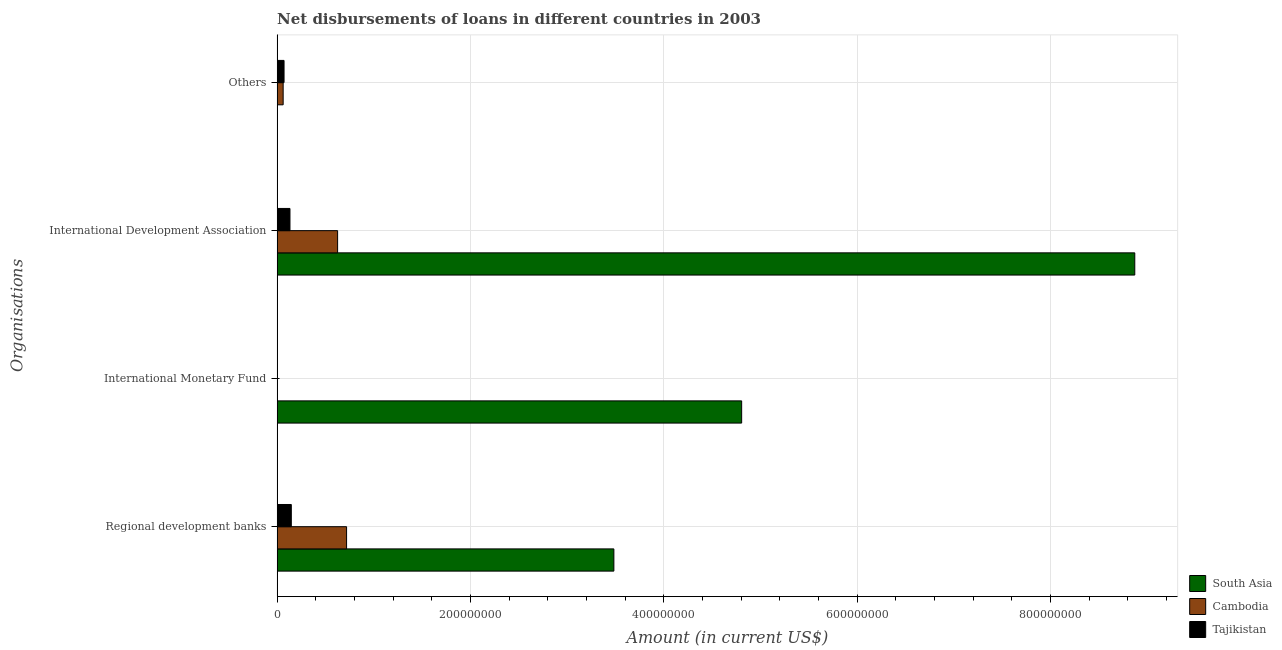How many different coloured bars are there?
Keep it short and to the point. 3. Are the number of bars per tick equal to the number of legend labels?
Your answer should be compact. No. How many bars are there on the 1st tick from the bottom?
Your answer should be very brief. 3. What is the label of the 1st group of bars from the top?
Keep it short and to the point. Others. What is the amount of loan disimbursed by international development association in Cambodia?
Offer a terse response. 6.26e+07. Across all countries, what is the maximum amount of loan disimbursed by international development association?
Offer a terse response. 8.87e+08. Across all countries, what is the minimum amount of loan disimbursed by regional development banks?
Make the answer very short. 1.47e+07. In which country was the amount of loan disimbursed by other organisations maximum?
Your answer should be very brief. Tajikistan. What is the total amount of loan disimbursed by international development association in the graph?
Your response must be concise. 9.63e+08. What is the difference between the amount of loan disimbursed by regional development banks in South Asia and that in Tajikistan?
Keep it short and to the point. 3.34e+08. What is the difference between the amount of loan disimbursed by regional development banks in South Asia and the amount of loan disimbursed by international development association in Tajikistan?
Offer a very short reply. 3.35e+08. What is the average amount of loan disimbursed by international development association per country?
Provide a succinct answer. 3.21e+08. What is the difference between the amount of loan disimbursed by other organisations and amount of loan disimbursed by international development association in Tajikistan?
Your answer should be compact. -6.12e+06. In how many countries, is the amount of loan disimbursed by international monetary fund greater than 160000000 US$?
Make the answer very short. 1. What is the ratio of the amount of loan disimbursed by international development association in South Asia to that in Cambodia?
Your answer should be very brief. 14.18. Is the difference between the amount of loan disimbursed by regional development banks in South Asia and Tajikistan greater than the difference between the amount of loan disimbursed by international development association in South Asia and Tajikistan?
Keep it short and to the point. No. What is the difference between the highest and the second highest amount of loan disimbursed by international development association?
Your answer should be very brief. 8.25e+08. What is the difference between the highest and the lowest amount of loan disimbursed by other organisations?
Make the answer very short. 7.17e+06. Is the sum of the amount of loan disimbursed by international development association in Cambodia and Tajikistan greater than the maximum amount of loan disimbursed by other organisations across all countries?
Offer a terse response. Yes. Is it the case that in every country, the sum of the amount of loan disimbursed by international development association and amount of loan disimbursed by regional development banks is greater than the sum of amount of loan disimbursed by other organisations and amount of loan disimbursed by international monetary fund?
Your answer should be compact. No. How many bars are there?
Make the answer very short. 9. Are all the bars in the graph horizontal?
Your response must be concise. Yes. How many countries are there in the graph?
Your answer should be compact. 3. How many legend labels are there?
Provide a short and direct response. 3. How are the legend labels stacked?
Your response must be concise. Vertical. What is the title of the graph?
Provide a short and direct response. Net disbursements of loans in different countries in 2003. Does "Cayman Islands" appear as one of the legend labels in the graph?
Provide a short and direct response. No. What is the label or title of the X-axis?
Offer a very short reply. Amount (in current US$). What is the label or title of the Y-axis?
Your response must be concise. Organisations. What is the Amount (in current US$) in South Asia in Regional development banks?
Offer a terse response. 3.48e+08. What is the Amount (in current US$) of Cambodia in Regional development banks?
Provide a short and direct response. 7.18e+07. What is the Amount (in current US$) of Tajikistan in Regional development banks?
Offer a terse response. 1.47e+07. What is the Amount (in current US$) of South Asia in International Monetary Fund?
Your answer should be very brief. 4.80e+08. What is the Amount (in current US$) of Cambodia in International Monetary Fund?
Keep it short and to the point. 0. What is the Amount (in current US$) in Tajikistan in International Monetary Fund?
Your answer should be compact. 0. What is the Amount (in current US$) of South Asia in International Development Association?
Your response must be concise. 8.87e+08. What is the Amount (in current US$) of Cambodia in International Development Association?
Ensure brevity in your answer.  6.26e+07. What is the Amount (in current US$) of Tajikistan in International Development Association?
Offer a terse response. 1.33e+07. What is the Amount (in current US$) in Cambodia in Others?
Your response must be concise. 6.24e+06. What is the Amount (in current US$) of Tajikistan in Others?
Your response must be concise. 7.17e+06. Across all Organisations, what is the maximum Amount (in current US$) of South Asia?
Provide a short and direct response. 8.87e+08. Across all Organisations, what is the maximum Amount (in current US$) in Cambodia?
Provide a succinct answer. 7.18e+07. Across all Organisations, what is the maximum Amount (in current US$) in Tajikistan?
Your answer should be compact. 1.47e+07. Across all Organisations, what is the minimum Amount (in current US$) in Cambodia?
Offer a terse response. 0. Across all Organisations, what is the minimum Amount (in current US$) of Tajikistan?
Give a very brief answer. 0. What is the total Amount (in current US$) of South Asia in the graph?
Your response must be concise. 1.72e+09. What is the total Amount (in current US$) in Cambodia in the graph?
Your answer should be compact. 1.41e+08. What is the total Amount (in current US$) in Tajikistan in the graph?
Provide a short and direct response. 3.51e+07. What is the difference between the Amount (in current US$) of South Asia in Regional development banks and that in International Monetary Fund?
Your response must be concise. -1.32e+08. What is the difference between the Amount (in current US$) in South Asia in Regional development banks and that in International Development Association?
Give a very brief answer. -5.39e+08. What is the difference between the Amount (in current US$) in Cambodia in Regional development banks and that in International Development Association?
Offer a terse response. 9.28e+06. What is the difference between the Amount (in current US$) in Tajikistan in Regional development banks and that in International Development Association?
Offer a very short reply. 1.40e+06. What is the difference between the Amount (in current US$) of Cambodia in Regional development banks and that in Others?
Your answer should be very brief. 6.56e+07. What is the difference between the Amount (in current US$) in Tajikistan in Regional development banks and that in Others?
Provide a short and direct response. 7.51e+06. What is the difference between the Amount (in current US$) of South Asia in International Monetary Fund and that in International Development Association?
Ensure brevity in your answer.  -4.07e+08. What is the difference between the Amount (in current US$) in Cambodia in International Development Association and that in Others?
Make the answer very short. 5.63e+07. What is the difference between the Amount (in current US$) of Tajikistan in International Development Association and that in Others?
Ensure brevity in your answer.  6.12e+06. What is the difference between the Amount (in current US$) in South Asia in Regional development banks and the Amount (in current US$) in Cambodia in International Development Association?
Provide a succinct answer. 2.86e+08. What is the difference between the Amount (in current US$) in South Asia in Regional development banks and the Amount (in current US$) in Tajikistan in International Development Association?
Offer a terse response. 3.35e+08. What is the difference between the Amount (in current US$) of Cambodia in Regional development banks and the Amount (in current US$) of Tajikistan in International Development Association?
Give a very brief answer. 5.86e+07. What is the difference between the Amount (in current US$) of South Asia in Regional development banks and the Amount (in current US$) of Cambodia in Others?
Ensure brevity in your answer.  3.42e+08. What is the difference between the Amount (in current US$) in South Asia in Regional development banks and the Amount (in current US$) in Tajikistan in Others?
Keep it short and to the point. 3.41e+08. What is the difference between the Amount (in current US$) in Cambodia in Regional development banks and the Amount (in current US$) in Tajikistan in Others?
Ensure brevity in your answer.  6.47e+07. What is the difference between the Amount (in current US$) in South Asia in International Monetary Fund and the Amount (in current US$) in Cambodia in International Development Association?
Ensure brevity in your answer.  4.18e+08. What is the difference between the Amount (in current US$) of South Asia in International Monetary Fund and the Amount (in current US$) of Tajikistan in International Development Association?
Your answer should be very brief. 4.67e+08. What is the difference between the Amount (in current US$) in South Asia in International Monetary Fund and the Amount (in current US$) in Cambodia in Others?
Offer a very short reply. 4.74e+08. What is the difference between the Amount (in current US$) in South Asia in International Monetary Fund and the Amount (in current US$) in Tajikistan in Others?
Your answer should be very brief. 4.73e+08. What is the difference between the Amount (in current US$) of South Asia in International Development Association and the Amount (in current US$) of Cambodia in Others?
Give a very brief answer. 8.81e+08. What is the difference between the Amount (in current US$) of South Asia in International Development Association and the Amount (in current US$) of Tajikistan in Others?
Keep it short and to the point. 8.80e+08. What is the difference between the Amount (in current US$) in Cambodia in International Development Association and the Amount (in current US$) in Tajikistan in Others?
Make the answer very short. 5.54e+07. What is the average Amount (in current US$) of South Asia per Organisations?
Provide a short and direct response. 4.29e+08. What is the average Amount (in current US$) of Cambodia per Organisations?
Offer a very short reply. 3.52e+07. What is the average Amount (in current US$) in Tajikistan per Organisations?
Provide a succinct answer. 8.78e+06. What is the difference between the Amount (in current US$) in South Asia and Amount (in current US$) in Cambodia in Regional development banks?
Offer a terse response. 2.76e+08. What is the difference between the Amount (in current US$) of South Asia and Amount (in current US$) of Tajikistan in Regional development banks?
Your response must be concise. 3.34e+08. What is the difference between the Amount (in current US$) in Cambodia and Amount (in current US$) in Tajikistan in Regional development banks?
Make the answer very short. 5.72e+07. What is the difference between the Amount (in current US$) in South Asia and Amount (in current US$) in Cambodia in International Development Association?
Your response must be concise. 8.25e+08. What is the difference between the Amount (in current US$) in South Asia and Amount (in current US$) in Tajikistan in International Development Association?
Give a very brief answer. 8.74e+08. What is the difference between the Amount (in current US$) of Cambodia and Amount (in current US$) of Tajikistan in International Development Association?
Make the answer very short. 4.93e+07. What is the difference between the Amount (in current US$) of Cambodia and Amount (in current US$) of Tajikistan in Others?
Offer a very short reply. -9.23e+05. What is the ratio of the Amount (in current US$) in South Asia in Regional development banks to that in International Monetary Fund?
Your response must be concise. 0.72. What is the ratio of the Amount (in current US$) in South Asia in Regional development banks to that in International Development Association?
Ensure brevity in your answer.  0.39. What is the ratio of the Amount (in current US$) in Cambodia in Regional development banks to that in International Development Association?
Give a very brief answer. 1.15. What is the ratio of the Amount (in current US$) in Tajikistan in Regional development banks to that in International Development Association?
Provide a short and direct response. 1.11. What is the ratio of the Amount (in current US$) in Cambodia in Regional development banks to that in Others?
Give a very brief answer. 11.51. What is the ratio of the Amount (in current US$) in Tajikistan in Regional development banks to that in Others?
Keep it short and to the point. 2.05. What is the ratio of the Amount (in current US$) in South Asia in International Monetary Fund to that in International Development Association?
Offer a very short reply. 0.54. What is the ratio of the Amount (in current US$) of Cambodia in International Development Association to that in Others?
Make the answer very short. 10.02. What is the ratio of the Amount (in current US$) of Tajikistan in International Development Association to that in Others?
Make the answer very short. 1.85. What is the difference between the highest and the second highest Amount (in current US$) in South Asia?
Give a very brief answer. 4.07e+08. What is the difference between the highest and the second highest Amount (in current US$) of Cambodia?
Offer a terse response. 9.28e+06. What is the difference between the highest and the second highest Amount (in current US$) of Tajikistan?
Offer a very short reply. 1.40e+06. What is the difference between the highest and the lowest Amount (in current US$) of South Asia?
Provide a succinct answer. 8.87e+08. What is the difference between the highest and the lowest Amount (in current US$) of Cambodia?
Provide a succinct answer. 7.18e+07. What is the difference between the highest and the lowest Amount (in current US$) in Tajikistan?
Offer a terse response. 1.47e+07. 